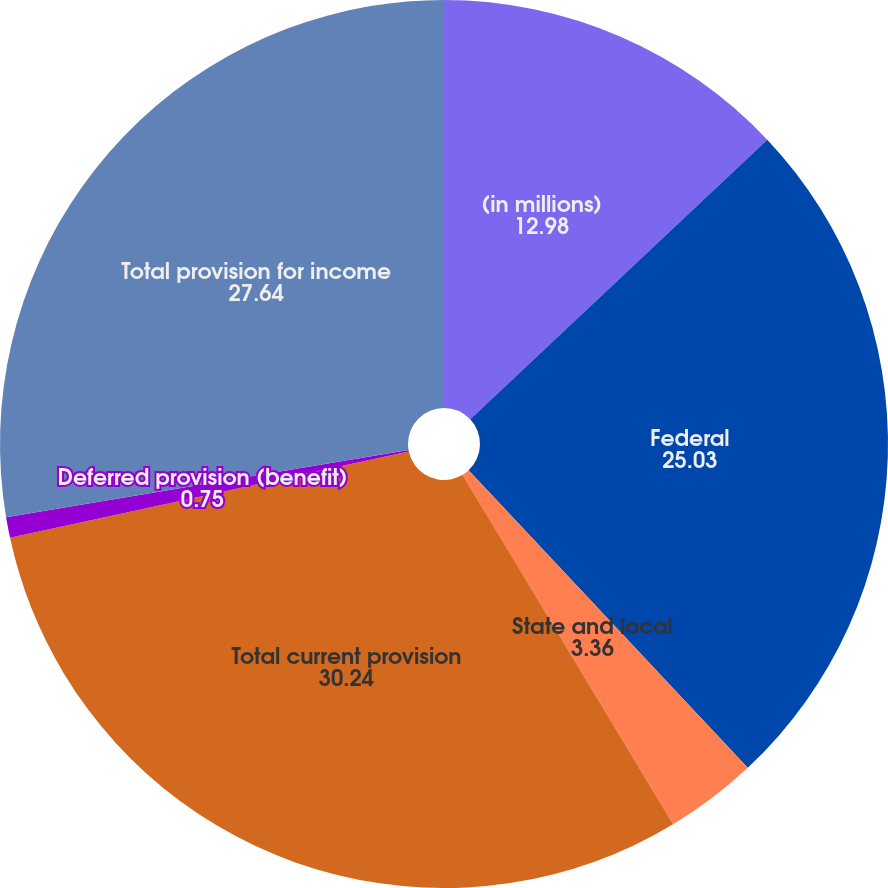Convert chart to OTSL. <chart><loc_0><loc_0><loc_500><loc_500><pie_chart><fcel>(in millions)<fcel>Federal<fcel>State and local<fcel>Total current provision<fcel>Deferred provision (benefit)<fcel>Total provision for income<nl><fcel>12.98%<fcel>25.03%<fcel>3.36%<fcel>30.24%<fcel>0.75%<fcel>27.64%<nl></chart> 